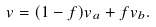<formula> <loc_0><loc_0><loc_500><loc_500>v = ( 1 - f ) v _ { a } + f v _ { b } .</formula> 